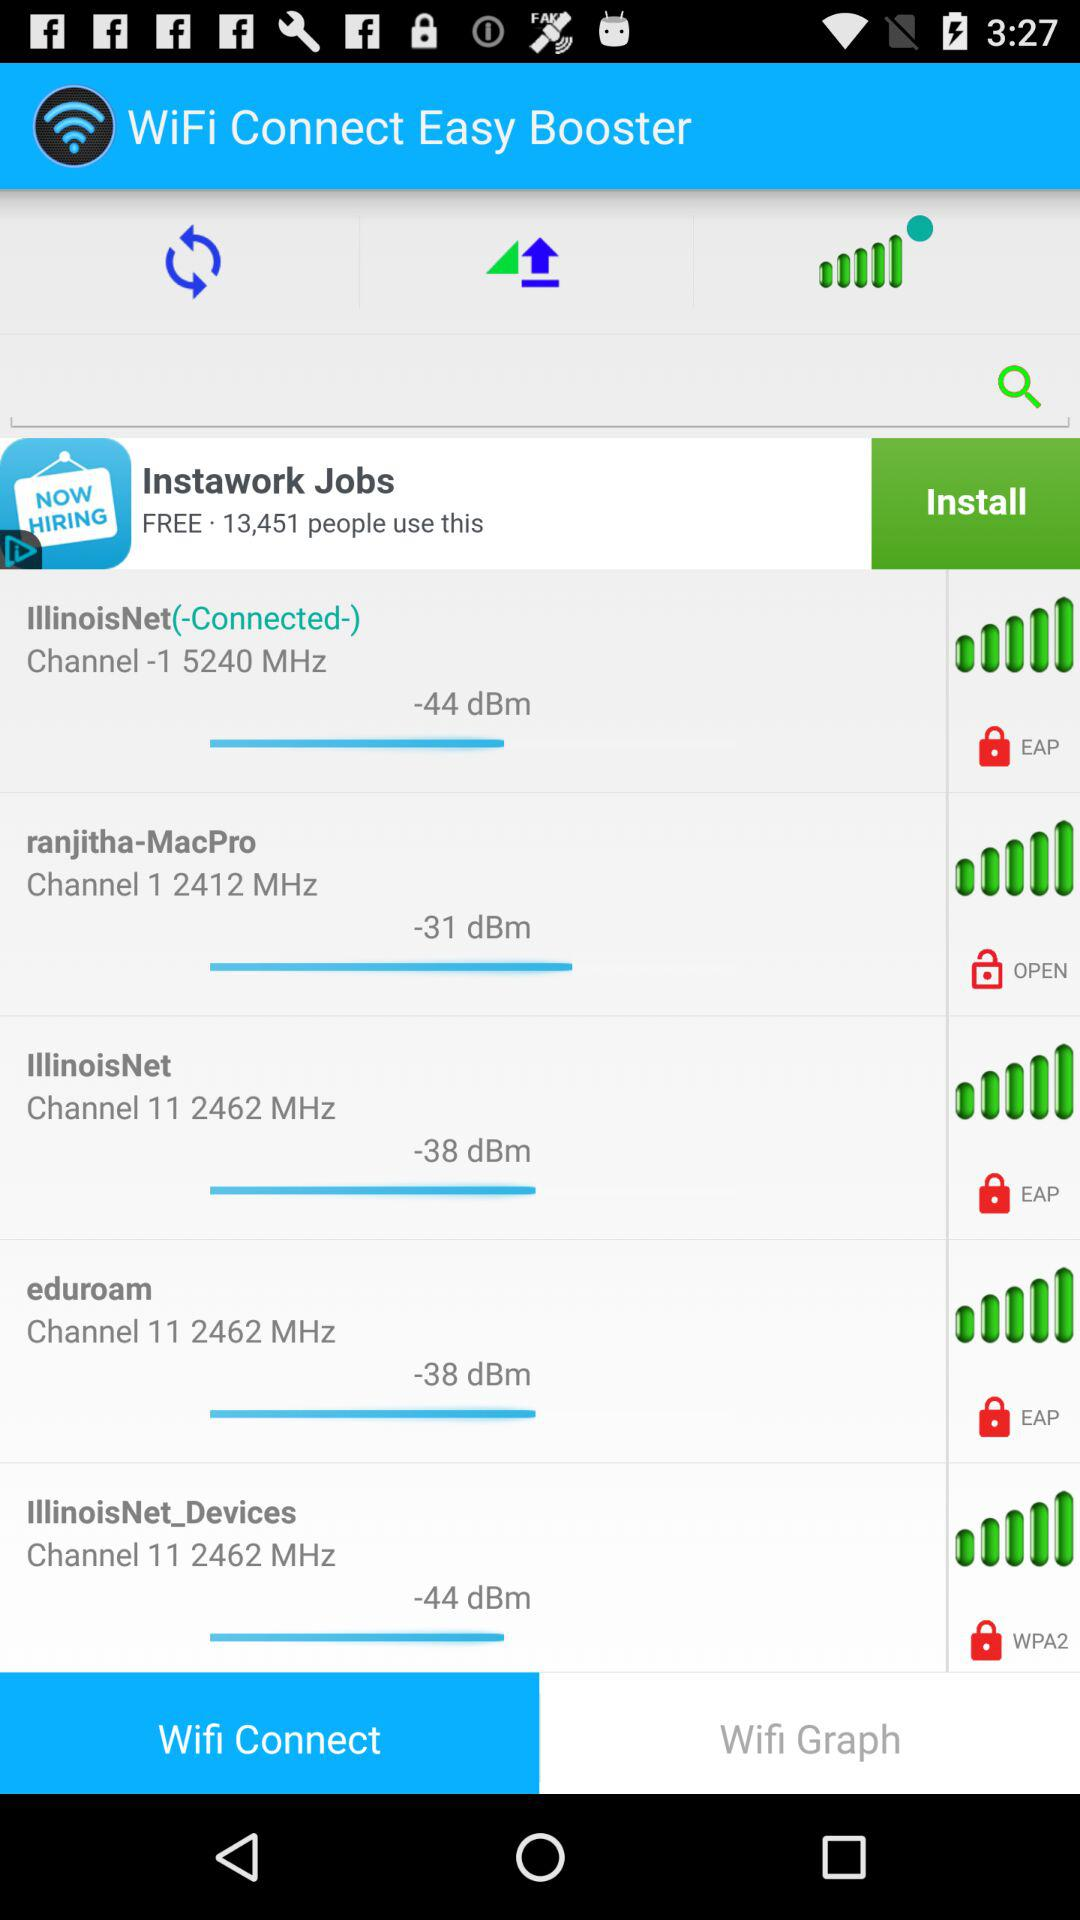What is the name of the network which channel name is 112462MHz?
When the provided information is insufficient, respond with <no answer>. <no answer> 